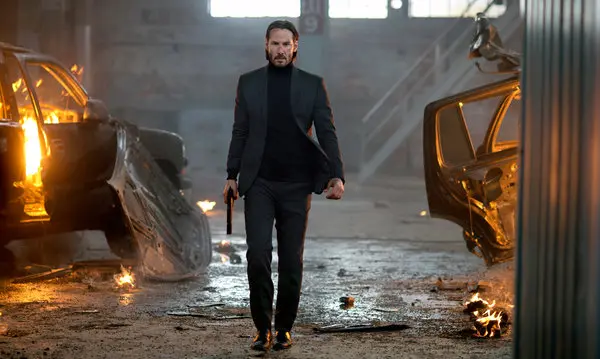Imagine a fantastical scenario involving this character. What could it be? In a fantastical scenario, this character could be a time-traveling warrior from the future, tasked with saving humanity from an impending apocalypse. The burning cars and debris around him are remnants of a futuristic battle against rogue AI entities that have taken over the world. His mission involves traveling through different eras to collect ancient artifacts that hold the key to defeating the AI menace. The man’s suit is no ordinary attire but a high-tech armor equipped with various gadgets and weapons that aid him in his perilous journey. As he strides through the burning remains of his latest skirmish, he is already planning his next move, driven by a determination to restore peace to a shattered world. What kind of abilities might this character possess in such a fantastical context? In this fantastical context, the character could possess abilities such as enhanced reflexes and strength, allowing him to handle multiple adversaries with ease. His suit might have cloaking technology for stealth missions and built-in AI for tactical assistance. He could have a mastery of advanced weaponry and combat skills, as well as the ability to manipulate time slightly, giving him a crucial edge in battles. These abilities, combined with his resilience and strategic mind, would make him a formidable protector of humanity against the encroaching AI threat. 